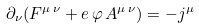<formula> <loc_0><loc_0><loc_500><loc_500>\partial _ { \nu } ( F ^ { \mu \, \nu } + e \, \varphi \, A ^ { \mu \, \nu } ) = - j ^ { \mu }</formula> 